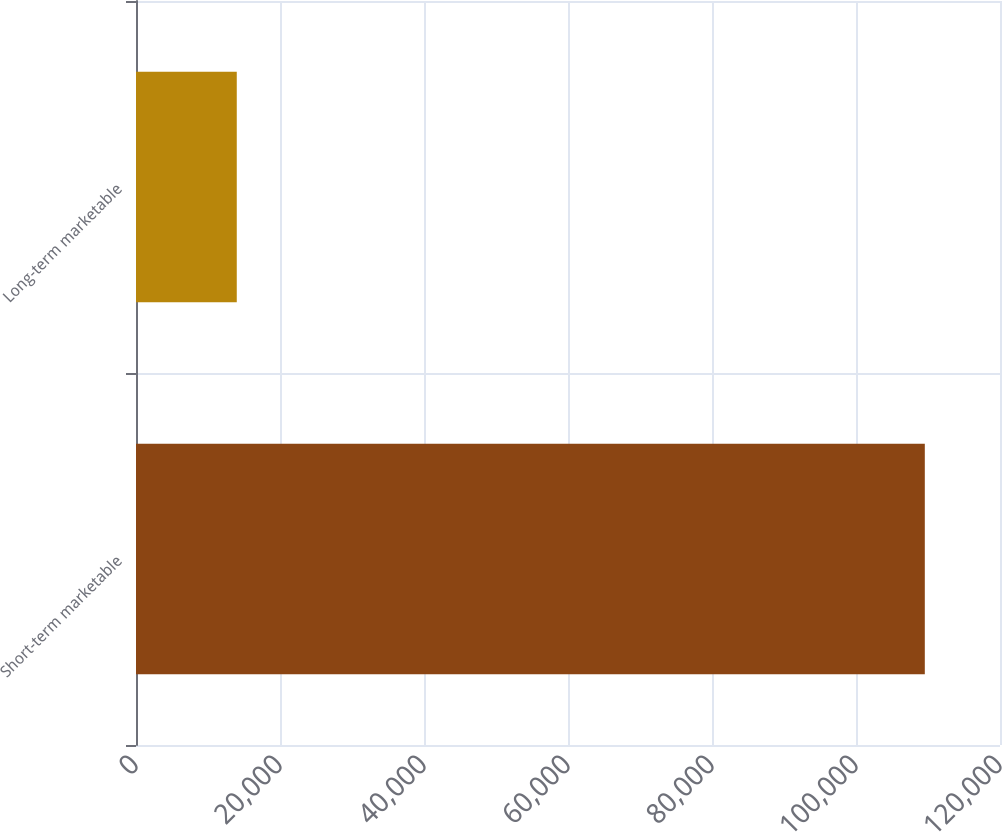<chart> <loc_0><loc_0><loc_500><loc_500><bar_chart><fcel>Short-term marketable<fcel>Long-term marketable<nl><fcel>109557<fcel>13996<nl></chart> 